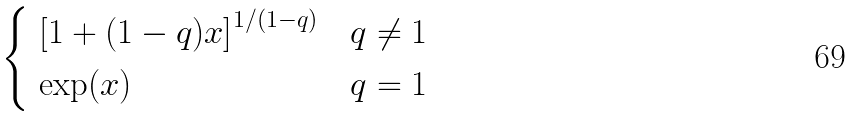<formula> <loc_0><loc_0><loc_500><loc_500>\begin{cases} \ \left [ 1 + ( 1 - q ) x \right ] ^ { 1 / ( 1 - q ) } & q \ne 1 \\ \ \exp ( x ) & q = 1 \end{cases}</formula> 